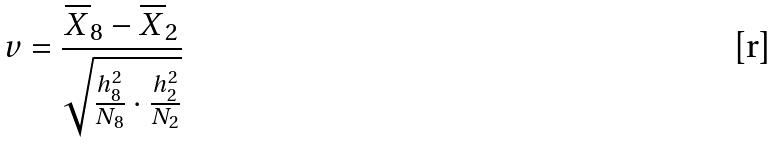Convert formula to latex. <formula><loc_0><loc_0><loc_500><loc_500>v = \frac { \overline { X } _ { 8 } - \overline { X } _ { 2 } } { \sqrt { \frac { h _ { 8 } ^ { 2 } } { N _ { 8 } } \cdot \frac { h _ { 2 } ^ { 2 } } { N _ { 2 } } } }</formula> 